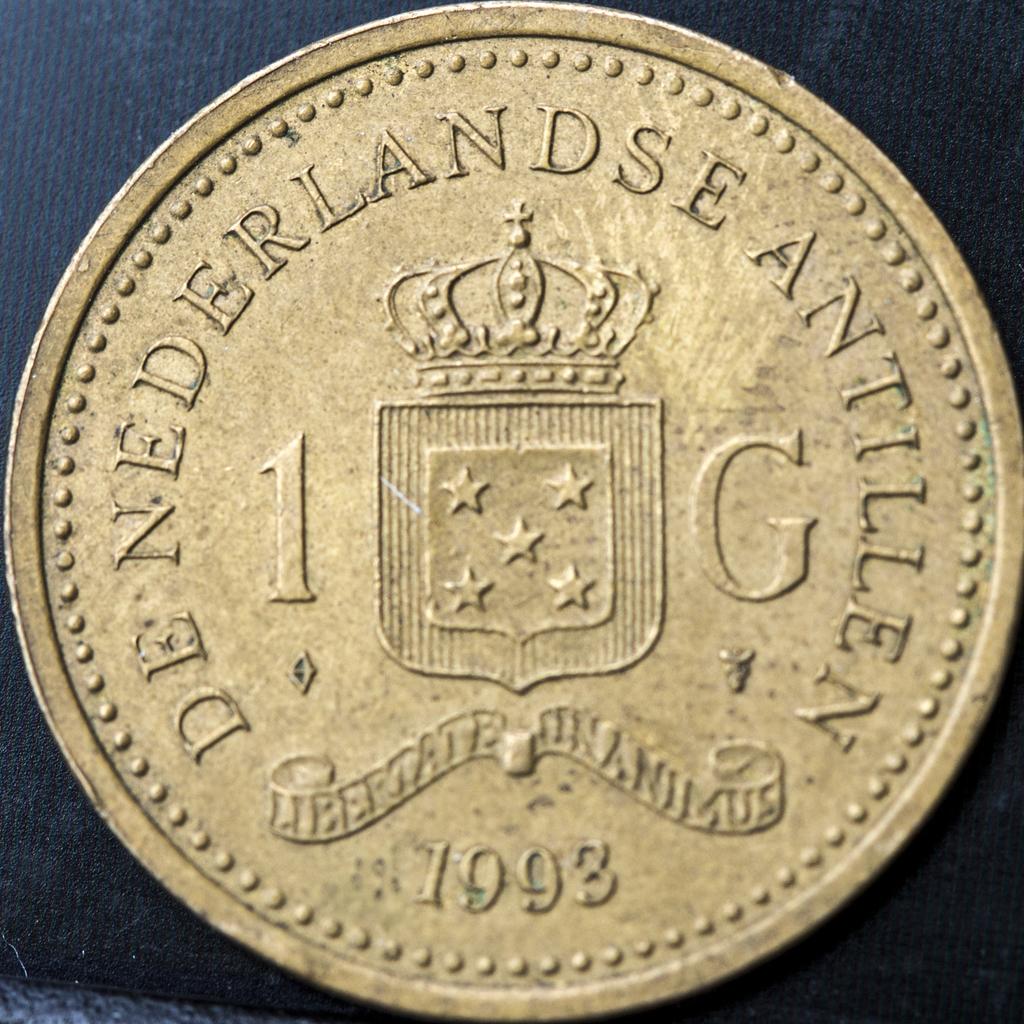What year was this coin minted?
Your answer should be very brief. 1993. What country is this coin from?
Your response must be concise. Nederlands. 